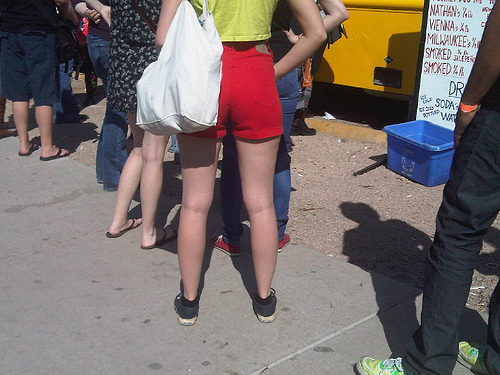<image>
Can you confirm if the shorts is on the woman? No. The shorts is not positioned on the woman. They may be near each other, but the shorts is not supported by or resting on top of the woman. 